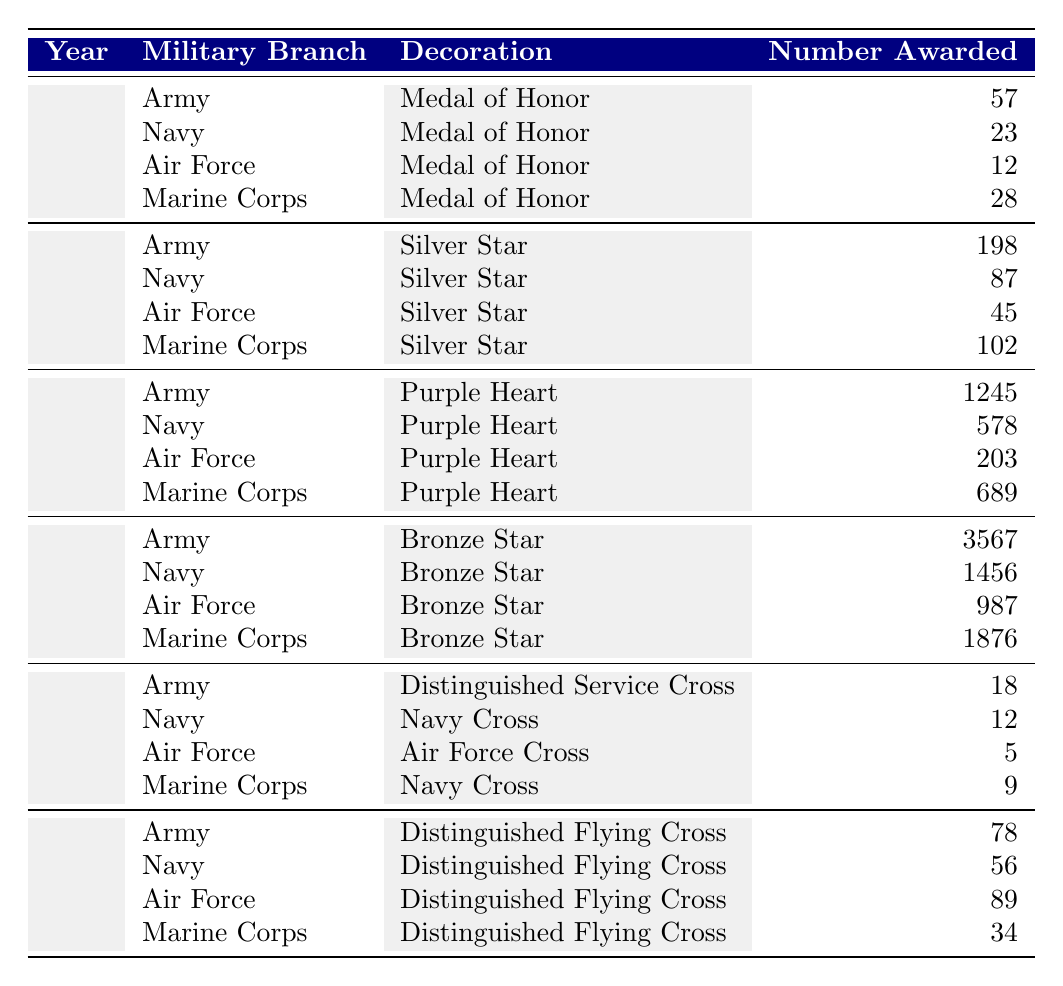What is the highest number of "Medal of Honor" awarded in a single year? Looking at the year 1970, the Army received 57 awards, the Navy 23, the Air Force 12, and the Marine Corps 28. The highest number is 57 awarded to the Army.
Answer: 57 In which year did the Army receive the most "Purple Heart" decorations? The table shows that in 1990, the Army received 1245 "Purple Heart" decorations, which is higher than any other year listed.
Answer: 1990 How many "Bronze Star" decorations were awarded to the Navy in the year 2000? Referring to the table, the number awarded to the Navy in 2000 is listed as 1456.
Answer: 1456 What decoration had the lowest number awarded to the Air Force in 2010? The Air Force received 5 "Air Force Cross" awards in 2010, which is the lowest number compared to the other decorations in the same year.
Answer: 5 What is the total number of "Distinguished Flying Cross" awarded to all branches in 2020? Adding the figures from the table, we have 78 (Army) + 56 (Navy) + 89 (Air Force) + 34 (Marine Corps) = 257.
Answer: 257 Is the number of "Silver Star" awards given to the Marine Corps higher than that given to the Navy in 1980? The Marine Corps received 102 "Silver Star" awards, while the Navy received 87. Since 102 is greater than 87, the statement is true.
Answer: Yes In which year did the Navy receive the least number of "Medal of Honor" decorations? The table shows that in 1970, the Navy received 23 "Medal of Honor" decorations, which is the only year and number provided, indicating it's the least.
Answer: 1970 Which military branch received the most "Bronze Star" decorations in the listed years? In the year 2000, the Army received 3567 "Bronze Star" decorations, more than any other branch in the same year or across the years shown.
Answer: Army What is the difference in the number of "Navy Cross" awarded to the Navy and Marine Corps in 2010? The Navy received 12 "Navy Cross" decorations, and the Marine Corps received 9. The difference is 12 - 9 = 3.
Answer: 3 What percentage of the total "Purple Heart" decorations awarded in 1990 were given to the Army? In 1990, the Army received 1245, and the total awarded that year was 1245 + 578 + 203 + 689 = 2715. The percentage is (1245/2715) * 100 ≈ 45.8%.
Answer: 45.8% 